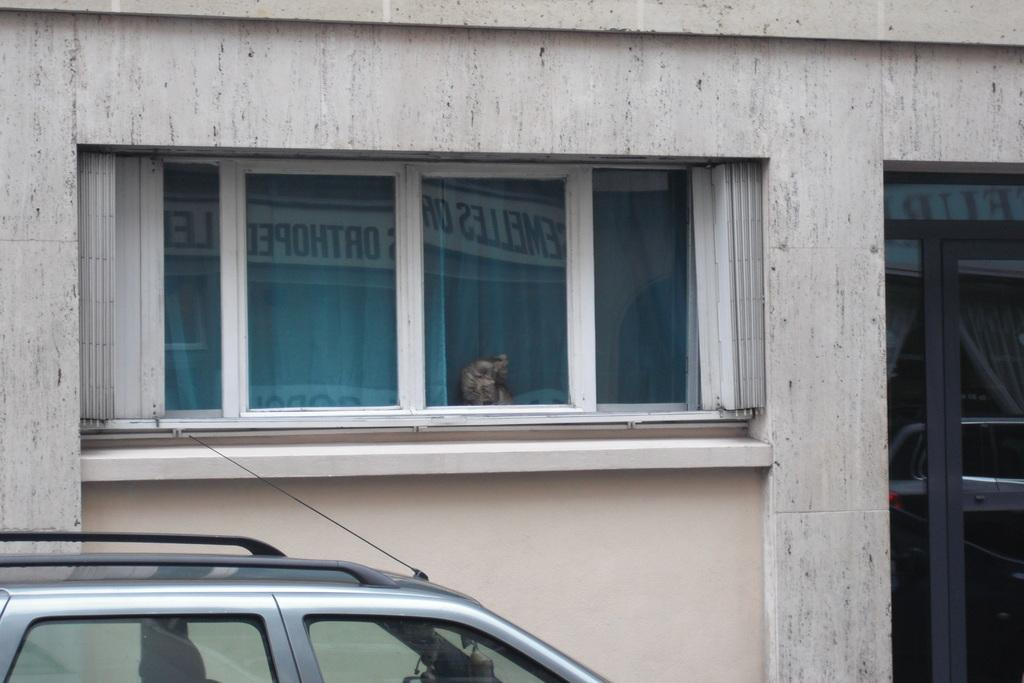What type of structure is visible in the image? There is a building in the image. What features can be seen on the building? The building has doors and windows. Is there any animal present in the image? Yes, a cat is sitting near a window. What is the location of the car in the image? The car is on the left bottom of the image. What type of creature can be seen exhibiting unusual behavior in the image? There is no creature exhibiting unusual behavior in the image. The cat is simply sitting near a window. What design elements can be seen on the building's facade in the image? The provided facts do not mention any specific design elements on the building's facade. 